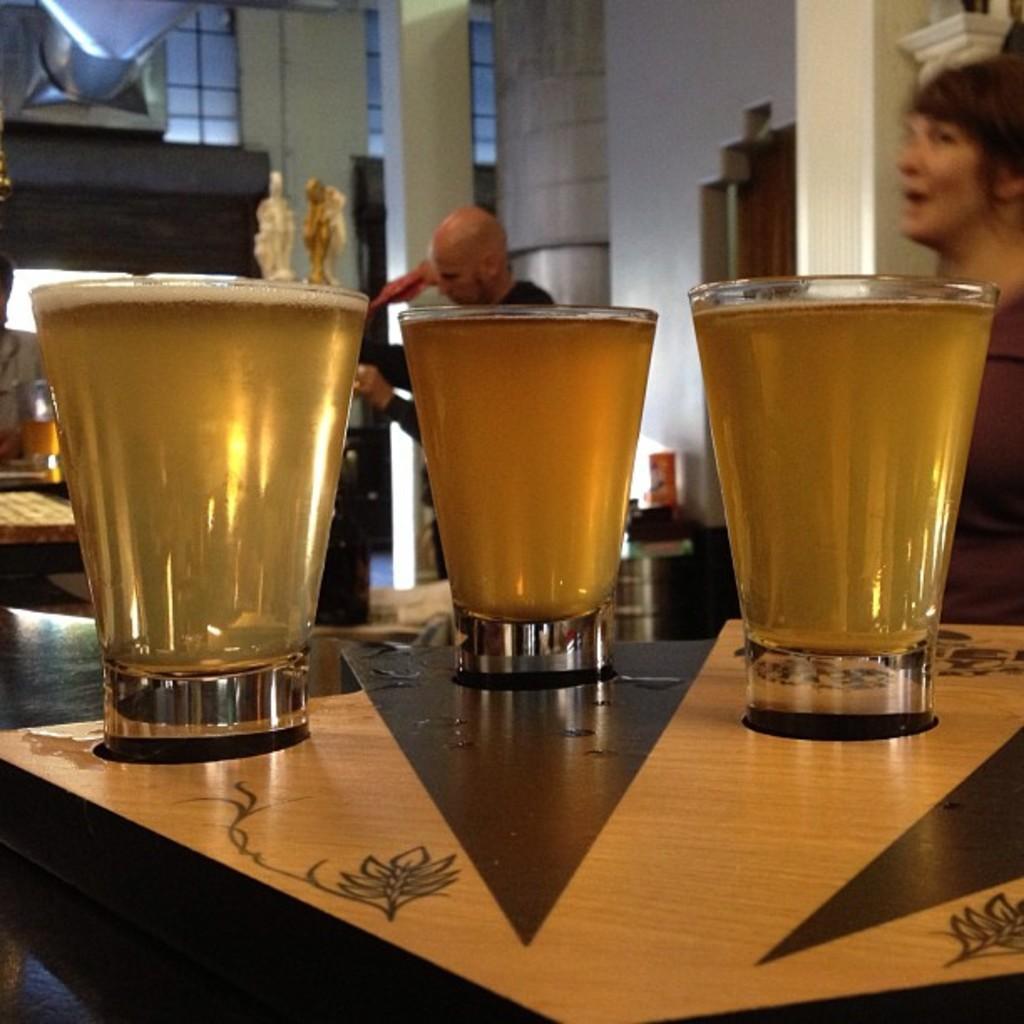Describe this image in one or two sentences. In this image I can see three glasses on the table. At the back side there is a building. 